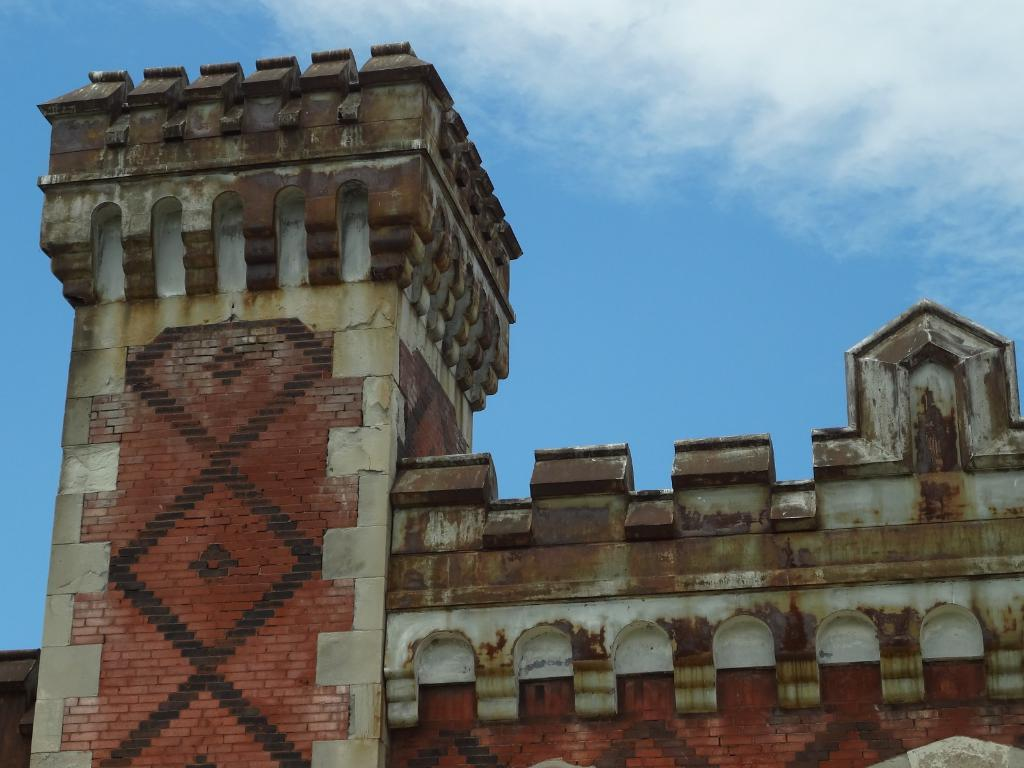What type of structure can be seen in the image? There is a building in the image. What part of the natural environment is visible in the image? The sky is visible in the image. What type of sail can be seen on the building in the image? There is no sail present on the building in the image. 